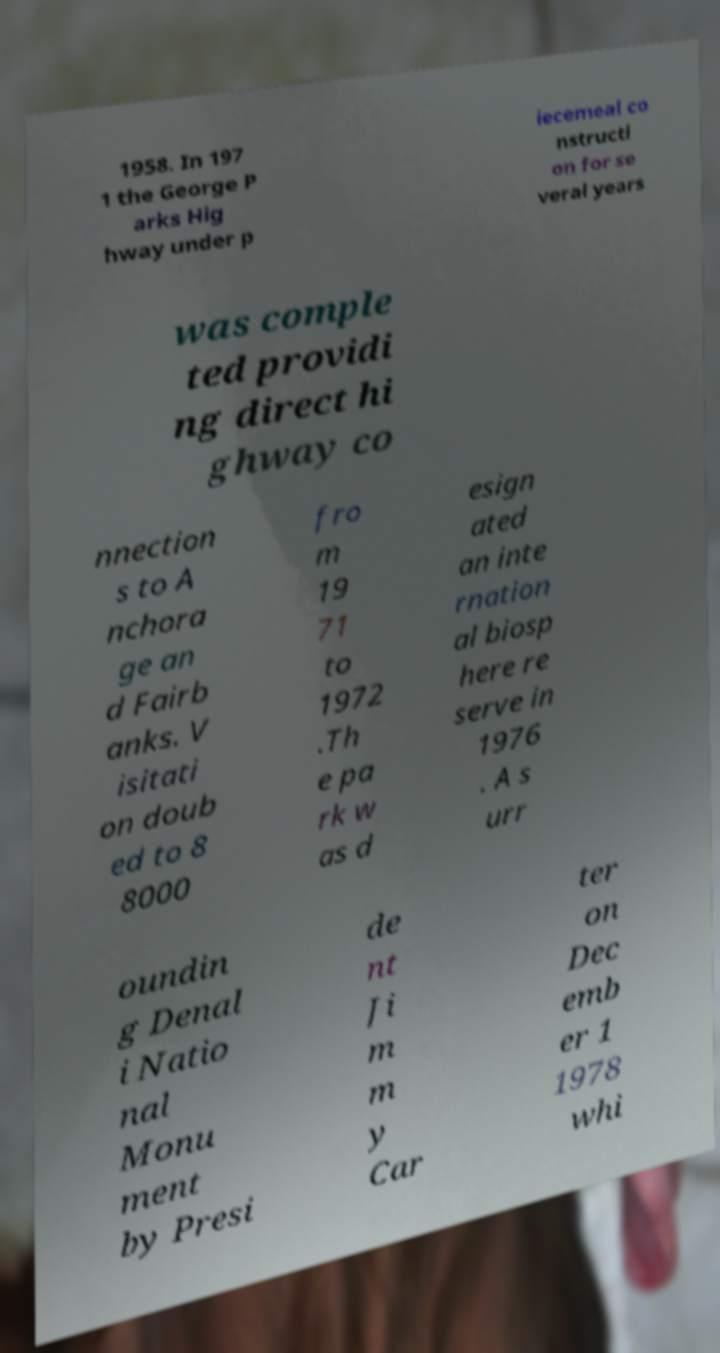Could you assist in decoding the text presented in this image and type it out clearly? 1958. In 197 1 the George P arks Hig hway under p iecemeal co nstructi on for se veral years was comple ted providi ng direct hi ghway co nnection s to A nchora ge an d Fairb anks. V isitati on doub ed to 8 8000 fro m 19 71 to 1972 .Th e pa rk w as d esign ated an inte rnation al biosp here re serve in 1976 . A s urr oundin g Denal i Natio nal Monu ment by Presi de nt Ji m m y Car ter on Dec emb er 1 1978 whi 